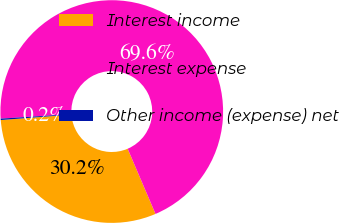Convert chart to OTSL. <chart><loc_0><loc_0><loc_500><loc_500><pie_chart><fcel>Interest income<fcel>Interest expense<fcel>Other income (expense) net<nl><fcel>30.21%<fcel>69.59%<fcel>0.2%<nl></chart> 